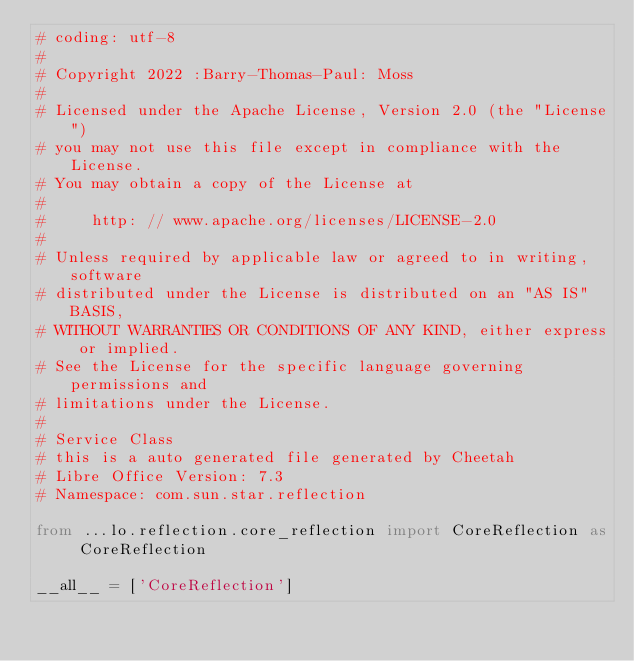Convert code to text. <code><loc_0><loc_0><loc_500><loc_500><_Python_># coding: utf-8
#
# Copyright 2022 :Barry-Thomas-Paul: Moss
#
# Licensed under the Apache License, Version 2.0 (the "License")
# you may not use this file except in compliance with the License.
# You may obtain a copy of the License at
#
#     http: // www.apache.org/licenses/LICENSE-2.0
#
# Unless required by applicable law or agreed to in writing, software
# distributed under the License is distributed on an "AS IS" BASIS,
# WITHOUT WARRANTIES OR CONDITIONS OF ANY KIND, either express or implied.
# See the License for the specific language governing permissions and
# limitations under the License.
#
# Service Class
# this is a auto generated file generated by Cheetah
# Libre Office Version: 7.3
# Namespace: com.sun.star.reflection

from ...lo.reflection.core_reflection import CoreReflection as CoreReflection

__all__ = ['CoreReflection']

</code> 